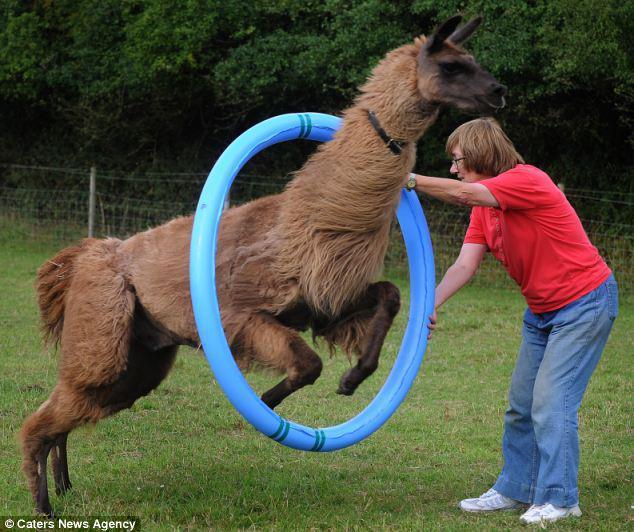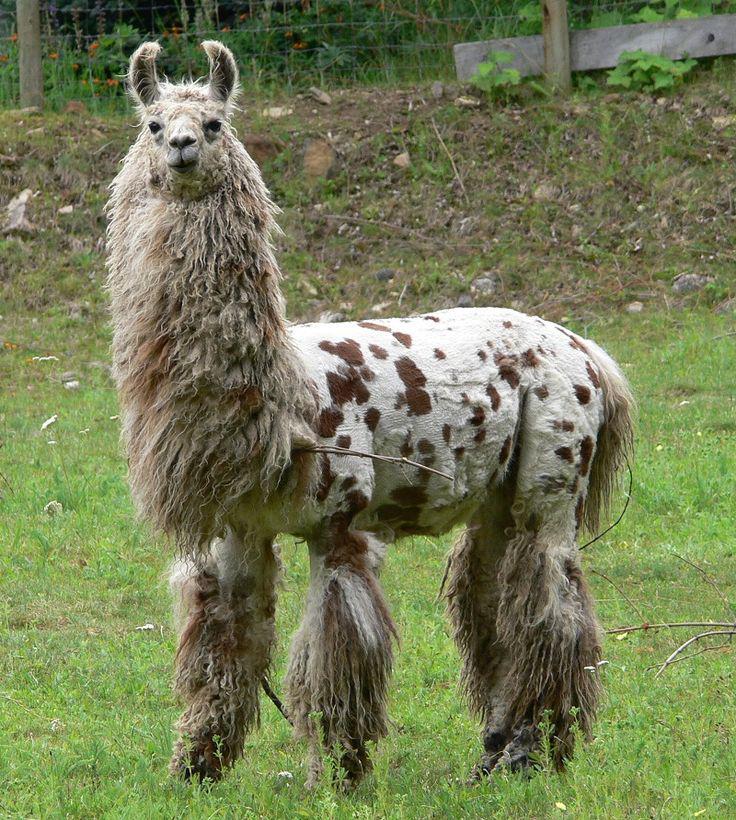The first image is the image on the left, the second image is the image on the right. Evaluate the accuracy of this statement regarding the images: "Each image features exactly two llamas in the foreground.". Is it true? Answer yes or no. No. The first image is the image on the left, the second image is the image on the right. Examine the images to the left and right. Is the description "Two llamas have brown ears." accurate? Answer yes or no. No. 